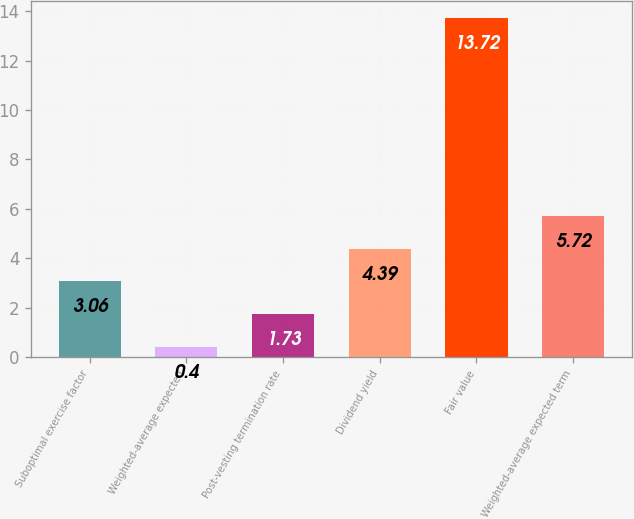Convert chart. <chart><loc_0><loc_0><loc_500><loc_500><bar_chart><fcel>Suboptimal exercise factor<fcel>Weighted-average expected<fcel>Post-vesting termination rate<fcel>Dividend yield<fcel>Fair value<fcel>Weighted-average expected term<nl><fcel>3.06<fcel>0.4<fcel>1.73<fcel>4.39<fcel>13.72<fcel>5.72<nl></chart> 